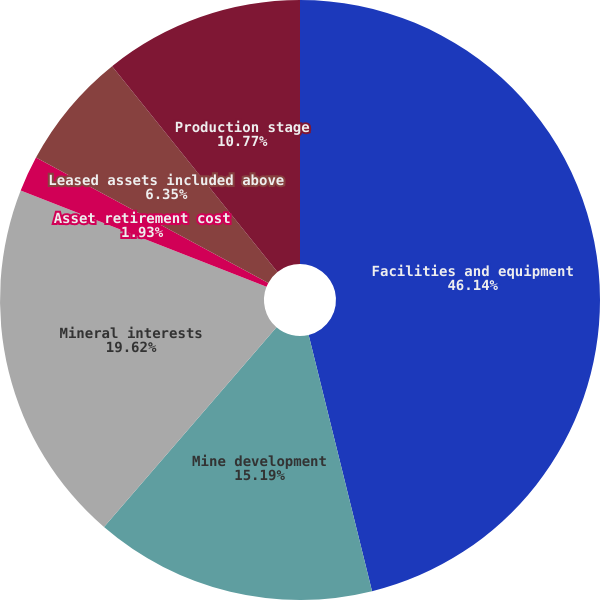Convert chart to OTSL. <chart><loc_0><loc_0><loc_500><loc_500><pie_chart><fcel>Facilities and equipment<fcel>Mine development<fcel>Mineral interests<fcel>Asset retirement cost<fcel>Leased assets included above<fcel>Production stage<nl><fcel>46.13%<fcel>15.19%<fcel>19.61%<fcel>1.93%<fcel>6.35%<fcel>10.77%<nl></chart> 